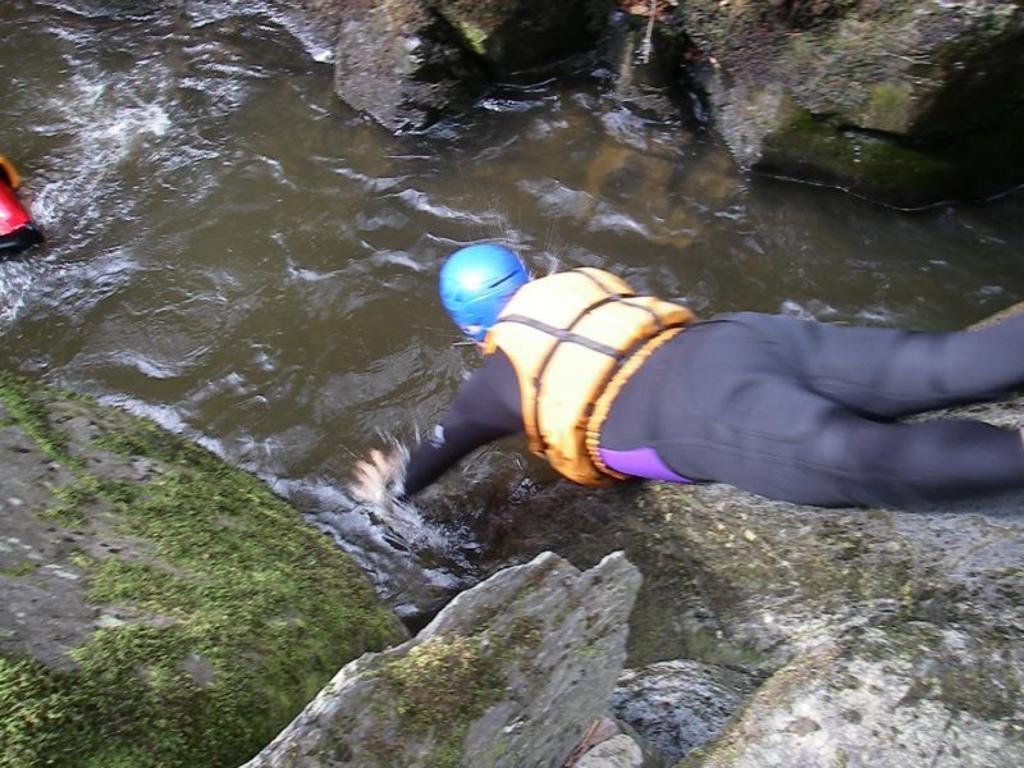Could you give a brief overview of what you see in this image? As we can see in the image there is a river in which the man is diving and beside it there are rocks. The man is wearing blue helmet, life jacket which is in orange colour and a track suit which is in black colour. 